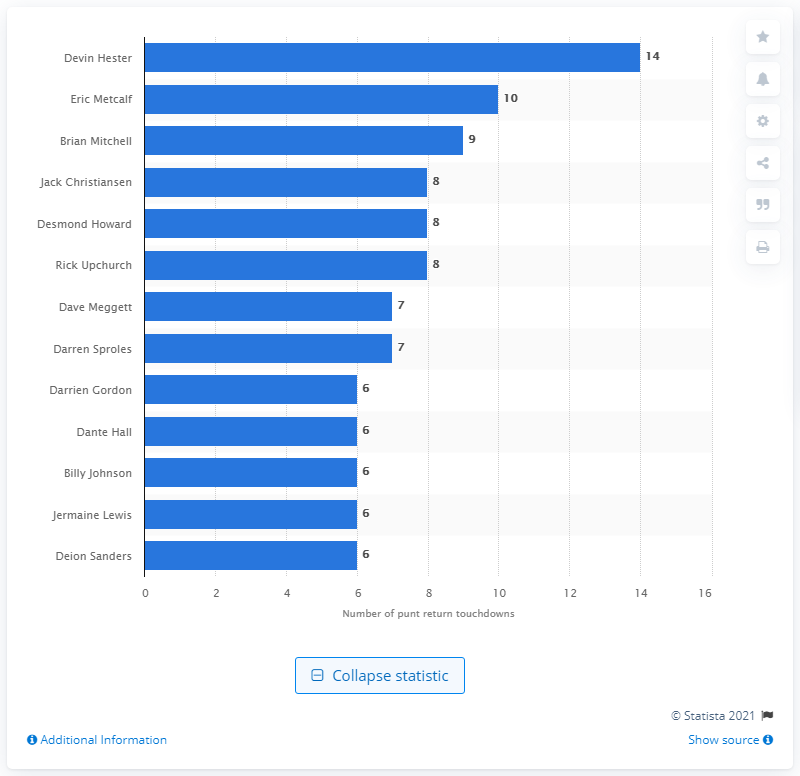Point out several critical features in this image. Devin Hester holds the record for the most punt return touchdowns in NFL history. 